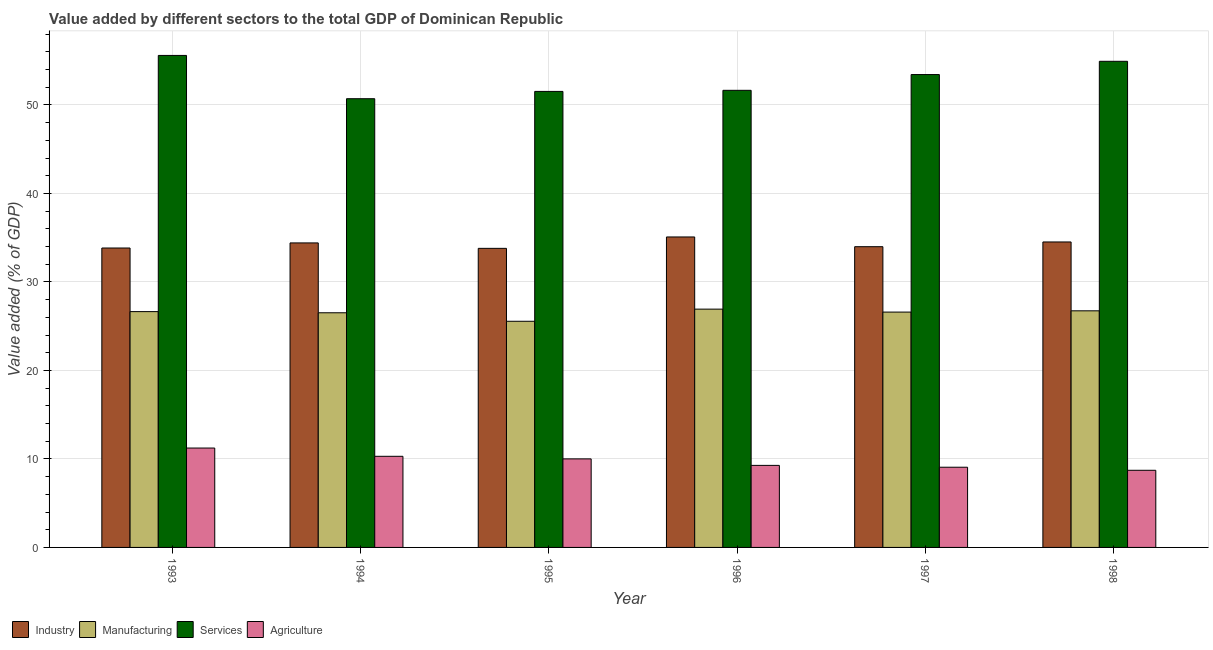How many different coloured bars are there?
Your response must be concise. 4. Are the number of bars on each tick of the X-axis equal?
Provide a short and direct response. Yes. How many bars are there on the 1st tick from the left?
Offer a terse response. 4. How many bars are there on the 1st tick from the right?
Keep it short and to the point. 4. What is the value added by industrial sector in 1998?
Keep it short and to the point. 34.52. Across all years, what is the maximum value added by manufacturing sector?
Keep it short and to the point. 26.93. Across all years, what is the minimum value added by manufacturing sector?
Your response must be concise. 25.56. In which year was the value added by services sector minimum?
Provide a succinct answer. 1994. What is the total value added by services sector in the graph?
Make the answer very short. 317.86. What is the difference between the value added by industrial sector in 1993 and that in 1995?
Your answer should be compact. 0.04. What is the difference between the value added by services sector in 1995 and the value added by industrial sector in 1998?
Provide a short and direct response. -3.4. What is the average value added by agricultural sector per year?
Offer a very short reply. 9.76. What is the ratio of the value added by industrial sector in 1993 to that in 1995?
Provide a short and direct response. 1. Is the value added by services sector in 1994 less than that in 1998?
Your answer should be very brief. Yes. What is the difference between the highest and the second highest value added by manufacturing sector?
Your answer should be compact. 0.19. What is the difference between the highest and the lowest value added by industrial sector?
Give a very brief answer. 1.29. In how many years, is the value added by services sector greater than the average value added by services sector taken over all years?
Offer a terse response. 3. Is the sum of the value added by agricultural sector in 1993 and 1997 greater than the maximum value added by services sector across all years?
Make the answer very short. Yes. What does the 3rd bar from the left in 1993 represents?
Your answer should be very brief. Services. What does the 4th bar from the right in 1998 represents?
Provide a succinct answer. Industry. Is it the case that in every year, the sum of the value added by industrial sector and value added by manufacturing sector is greater than the value added by services sector?
Your answer should be very brief. Yes. How many years are there in the graph?
Your answer should be compact. 6. What is the difference between two consecutive major ticks on the Y-axis?
Give a very brief answer. 10. Where does the legend appear in the graph?
Offer a terse response. Bottom left. How are the legend labels stacked?
Your answer should be compact. Horizontal. What is the title of the graph?
Give a very brief answer. Value added by different sectors to the total GDP of Dominican Republic. Does "Natural Gas" appear as one of the legend labels in the graph?
Your answer should be compact. No. What is the label or title of the Y-axis?
Your response must be concise. Value added (% of GDP). What is the Value added (% of GDP) of Industry in 1993?
Give a very brief answer. 33.84. What is the Value added (% of GDP) in Manufacturing in 1993?
Ensure brevity in your answer.  26.65. What is the Value added (% of GDP) of Services in 1993?
Make the answer very short. 55.6. What is the Value added (% of GDP) in Agriculture in 1993?
Give a very brief answer. 11.23. What is the Value added (% of GDP) in Industry in 1994?
Your answer should be compact. 34.41. What is the Value added (% of GDP) in Manufacturing in 1994?
Offer a terse response. 26.52. What is the Value added (% of GDP) in Services in 1994?
Keep it short and to the point. 50.71. What is the Value added (% of GDP) in Agriculture in 1994?
Make the answer very short. 10.3. What is the Value added (% of GDP) in Industry in 1995?
Keep it short and to the point. 33.8. What is the Value added (% of GDP) of Manufacturing in 1995?
Give a very brief answer. 25.56. What is the Value added (% of GDP) in Services in 1995?
Ensure brevity in your answer.  51.53. What is the Value added (% of GDP) of Agriculture in 1995?
Provide a short and direct response. 10.01. What is the Value added (% of GDP) of Industry in 1996?
Offer a very short reply. 35.08. What is the Value added (% of GDP) in Manufacturing in 1996?
Provide a succinct answer. 26.93. What is the Value added (% of GDP) in Services in 1996?
Your response must be concise. 51.66. What is the Value added (% of GDP) of Agriculture in 1996?
Your answer should be compact. 9.27. What is the Value added (% of GDP) in Industry in 1997?
Your answer should be very brief. 33.98. What is the Value added (% of GDP) in Manufacturing in 1997?
Ensure brevity in your answer.  26.59. What is the Value added (% of GDP) in Services in 1997?
Keep it short and to the point. 53.44. What is the Value added (% of GDP) in Agriculture in 1997?
Your answer should be very brief. 9.06. What is the Value added (% of GDP) of Industry in 1998?
Give a very brief answer. 34.52. What is the Value added (% of GDP) in Manufacturing in 1998?
Offer a terse response. 26.74. What is the Value added (% of GDP) of Services in 1998?
Your answer should be very brief. 54.93. What is the Value added (% of GDP) in Agriculture in 1998?
Keep it short and to the point. 8.72. Across all years, what is the maximum Value added (% of GDP) of Industry?
Offer a very short reply. 35.08. Across all years, what is the maximum Value added (% of GDP) of Manufacturing?
Your answer should be compact. 26.93. Across all years, what is the maximum Value added (% of GDP) of Services?
Offer a terse response. 55.6. Across all years, what is the maximum Value added (% of GDP) of Agriculture?
Ensure brevity in your answer.  11.23. Across all years, what is the minimum Value added (% of GDP) of Industry?
Make the answer very short. 33.8. Across all years, what is the minimum Value added (% of GDP) in Manufacturing?
Provide a short and direct response. 25.56. Across all years, what is the minimum Value added (% of GDP) of Services?
Your answer should be compact. 50.71. Across all years, what is the minimum Value added (% of GDP) of Agriculture?
Make the answer very short. 8.72. What is the total Value added (% of GDP) of Industry in the graph?
Keep it short and to the point. 205.63. What is the total Value added (% of GDP) in Manufacturing in the graph?
Make the answer very short. 158.98. What is the total Value added (% of GDP) in Services in the graph?
Provide a short and direct response. 317.86. What is the total Value added (% of GDP) of Agriculture in the graph?
Your answer should be very brief. 58.59. What is the difference between the Value added (% of GDP) of Industry in 1993 and that in 1994?
Your response must be concise. -0.57. What is the difference between the Value added (% of GDP) in Manufacturing in 1993 and that in 1994?
Your answer should be very brief. 0.13. What is the difference between the Value added (% of GDP) in Services in 1993 and that in 1994?
Ensure brevity in your answer.  4.89. What is the difference between the Value added (% of GDP) in Agriculture in 1993 and that in 1994?
Provide a succinct answer. 0.93. What is the difference between the Value added (% of GDP) of Industry in 1993 and that in 1995?
Provide a succinct answer. 0.04. What is the difference between the Value added (% of GDP) of Manufacturing in 1993 and that in 1995?
Your response must be concise. 1.09. What is the difference between the Value added (% of GDP) in Services in 1993 and that in 1995?
Provide a short and direct response. 4.07. What is the difference between the Value added (% of GDP) in Agriculture in 1993 and that in 1995?
Your answer should be compact. 1.23. What is the difference between the Value added (% of GDP) of Industry in 1993 and that in 1996?
Provide a succinct answer. -1.25. What is the difference between the Value added (% of GDP) of Manufacturing in 1993 and that in 1996?
Your answer should be very brief. -0.28. What is the difference between the Value added (% of GDP) in Services in 1993 and that in 1996?
Provide a short and direct response. 3.94. What is the difference between the Value added (% of GDP) of Agriculture in 1993 and that in 1996?
Provide a succinct answer. 1.96. What is the difference between the Value added (% of GDP) of Industry in 1993 and that in 1997?
Provide a succinct answer. -0.15. What is the difference between the Value added (% of GDP) of Manufacturing in 1993 and that in 1997?
Your response must be concise. 0.05. What is the difference between the Value added (% of GDP) in Services in 1993 and that in 1997?
Your response must be concise. 2.16. What is the difference between the Value added (% of GDP) in Agriculture in 1993 and that in 1997?
Give a very brief answer. 2.17. What is the difference between the Value added (% of GDP) in Industry in 1993 and that in 1998?
Give a very brief answer. -0.68. What is the difference between the Value added (% of GDP) of Manufacturing in 1993 and that in 1998?
Provide a succinct answer. -0.09. What is the difference between the Value added (% of GDP) in Services in 1993 and that in 1998?
Your answer should be compact. 0.66. What is the difference between the Value added (% of GDP) of Agriculture in 1993 and that in 1998?
Your answer should be compact. 2.51. What is the difference between the Value added (% of GDP) in Industry in 1994 and that in 1995?
Your answer should be very brief. 0.61. What is the difference between the Value added (% of GDP) in Manufacturing in 1994 and that in 1995?
Offer a terse response. 0.96. What is the difference between the Value added (% of GDP) of Services in 1994 and that in 1995?
Offer a terse response. -0.83. What is the difference between the Value added (% of GDP) in Agriculture in 1994 and that in 1995?
Ensure brevity in your answer.  0.29. What is the difference between the Value added (% of GDP) in Industry in 1994 and that in 1996?
Provide a short and direct response. -0.67. What is the difference between the Value added (% of GDP) of Manufacturing in 1994 and that in 1996?
Make the answer very short. -0.41. What is the difference between the Value added (% of GDP) of Services in 1994 and that in 1996?
Provide a short and direct response. -0.95. What is the difference between the Value added (% of GDP) in Agriculture in 1994 and that in 1996?
Your response must be concise. 1.03. What is the difference between the Value added (% of GDP) in Industry in 1994 and that in 1997?
Provide a short and direct response. 0.43. What is the difference between the Value added (% of GDP) of Manufacturing in 1994 and that in 1997?
Offer a very short reply. -0.08. What is the difference between the Value added (% of GDP) in Services in 1994 and that in 1997?
Ensure brevity in your answer.  -2.73. What is the difference between the Value added (% of GDP) in Agriculture in 1994 and that in 1997?
Provide a succinct answer. 1.23. What is the difference between the Value added (% of GDP) of Industry in 1994 and that in 1998?
Give a very brief answer. -0.11. What is the difference between the Value added (% of GDP) in Manufacturing in 1994 and that in 1998?
Offer a terse response. -0.22. What is the difference between the Value added (% of GDP) in Services in 1994 and that in 1998?
Your response must be concise. -4.23. What is the difference between the Value added (% of GDP) of Agriculture in 1994 and that in 1998?
Give a very brief answer. 1.58. What is the difference between the Value added (% of GDP) in Industry in 1995 and that in 1996?
Offer a terse response. -1.29. What is the difference between the Value added (% of GDP) of Manufacturing in 1995 and that in 1996?
Your answer should be compact. -1.37. What is the difference between the Value added (% of GDP) in Services in 1995 and that in 1996?
Offer a very short reply. -0.12. What is the difference between the Value added (% of GDP) in Agriculture in 1995 and that in 1996?
Give a very brief answer. 0.73. What is the difference between the Value added (% of GDP) of Industry in 1995 and that in 1997?
Keep it short and to the point. -0.19. What is the difference between the Value added (% of GDP) in Manufacturing in 1995 and that in 1997?
Your response must be concise. -1.04. What is the difference between the Value added (% of GDP) of Services in 1995 and that in 1997?
Your response must be concise. -1.91. What is the difference between the Value added (% of GDP) of Agriculture in 1995 and that in 1997?
Give a very brief answer. 0.94. What is the difference between the Value added (% of GDP) of Industry in 1995 and that in 1998?
Give a very brief answer. -0.72. What is the difference between the Value added (% of GDP) in Manufacturing in 1995 and that in 1998?
Give a very brief answer. -1.18. What is the difference between the Value added (% of GDP) of Services in 1995 and that in 1998?
Provide a succinct answer. -3.4. What is the difference between the Value added (% of GDP) in Agriculture in 1995 and that in 1998?
Your answer should be very brief. 1.29. What is the difference between the Value added (% of GDP) in Industry in 1996 and that in 1997?
Provide a short and direct response. 1.1. What is the difference between the Value added (% of GDP) of Manufacturing in 1996 and that in 1997?
Your answer should be very brief. 0.33. What is the difference between the Value added (% of GDP) of Services in 1996 and that in 1997?
Provide a succinct answer. -1.78. What is the difference between the Value added (% of GDP) of Agriculture in 1996 and that in 1997?
Offer a very short reply. 0.21. What is the difference between the Value added (% of GDP) of Industry in 1996 and that in 1998?
Keep it short and to the point. 0.57. What is the difference between the Value added (% of GDP) of Manufacturing in 1996 and that in 1998?
Offer a very short reply. 0.19. What is the difference between the Value added (% of GDP) in Services in 1996 and that in 1998?
Provide a succinct answer. -3.28. What is the difference between the Value added (% of GDP) of Agriculture in 1996 and that in 1998?
Provide a succinct answer. 0.55. What is the difference between the Value added (% of GDP) in Industry in 1997 and that in 1998?
Ensure brevity in your answer.  -0.54. What is the difference between the Value added (% of GDP) of Manufacturing in 1997 and that in 1998?
Offer a very short reply. -0.14. What is the difference between the Value added (% of GDP) of Services in 1997 and that in 1998?
Offer a terse response. -1.5. What is the difference between the Value added (% of GDP) of Agriculture in 1997 and that in 1998?
Give a very brief answer. 0.35. What is the difference between the Value added (% of GDP) in Industry in 1993 and the Value added (% of GDP) in Manufacturing in 1994?
Keep it short and to the point. 7.32. What is the difference between the Value added (% of GDP) in Industry in 1993 and the Value added (% of GDP) in Services in 1994?
Offer a terse response. -16.87. What is the difference between the Value added (% of GDP) of Industry in 1993 and the Value added (% of GDP) of Agriculture in 1994?
Provide a succinct answer. 23.54. What is the difference between the Value added (% of GDP) of Manufacturing in 1993 and the Value added (% of GDP) of Services in 1994?
Your response must be concise. -24.06. What is the difference between the Value added (% of GDP) in Manufacturing in 1993 and the Value added (% of GDP) in Agriculture in 1994?
Your response must be concise. 16.35. What is the difference between the Value added (% of GDP) in Services in 1993 and the Value added (% of GDP) in Agriculture in 1994?
Keep it short and to the point. 45.3. What is the difference between the Value added (% of GDP) in Industry in 1993 and the Value added (% of GDP) in Manufacturing in 1995?
Give a very brief answer. 8.28. What is the difference between the Value added (% of GDP) of Industry in 1993 and the Value added (% of GDP) of Services in 1995?
Your answer should be very brief. -17.7. What is the difference between the Value added (% of GDP) in Industry in 1993 and the Value added (% of GDP) in Agriculture in 1995?
Offer a terse response. 23.83. What is the difference between the Value added (% of GDP) in Manufacturing in 1993 and the Value added (% of GDP) in Services in 1995?
Keep it short and to the point. -24.88. What is the difference between the Value added (% of GDP) in Manufacturing in 1993 and the Value added (% of GDP) in Agriculture in 1995?
Provide a short and direct response. 16.64. What is the difference between the Value added (% of GDP) of Services in 1993 and the Value added (% of GDP) of Agriculture in 1995?
Make the answer very short. 45.59. What is the difference between the Value added (% of GDP) in Industry in 1993 and the Value added (% of GDP) in Manufacturing in 1996?
Ensure brevity in your answer.  6.91. What is the difference between the Value added (% of GDP) in Industry in 1993 and the Value added (% of GDP) in Services in 1996?
Make the answer very short. -17.82. What is the difference between the Value added (% of GDP) of Industry in 1993 and the Value added (% of GDP) of Agriculture in 1996?
Make the answer very short. 24.56. What is the difference between the Value added (% of GDP) of Manufacturing in 1993 and the Value added (% of GDP) of Services in 1996?
Provide a short and direct response. -25.01. What is the difference between the Value added (% of GDP) in Manufacturing in 1993 and the Value added (% of GDP) in Agriculture in 1996?
Ensure brevity in your answer.  17.38. What is the difference between the Value added (% of GDP) of Services in 1993 and the Value added (% of GDP) of Agriculture in 1996?
Give a very brief answer. 46.33. What is the difference between the Value added (% of GDP) of Industry in 1993 and the Value added (% of GDP) of Manufacturing in 1997?
Your response must be concise. 7.24. What is the difference between the Value added (% of GDP) of Industry in 1993 and the Value added (% of GDP) of Services in 1997?
Give a very brief answer. -19.6. What is the difference between the Value added (% of GDP) in Industry in 1993 and the Value added (% of GDP) in Agriculture in 1997?
Your answer should be very brief. 24.77. What is the difference between the Value added (% of GDP) in Manufacturing in 1993 and the Value added (% of GDP) in Services in 1997?
Make the answer very short. -26.79. What is the difference between the Value added (% of GDP) of Manufacturing in 1993 and the Value added (% of GDP) of Agriculture in 1997?
Your answer should be compact. 17.58. What is the difference between the Value added (% of GDP) of Services in 1993 and the Value added (% of GDP) of Agriculture in 1997?
Offer a very short reply. 46.53. What is the difference between the Value added (% of GDP) in Industry in 1993 and the Value added (% of GDP) in Manufacturing in 1998?
Ensure brevity in your answer.  7.1. What is the difference between the Value added (% of GDP) of Industry in 1993 and the Value added (% of GDP) of Services in 1998?
Provide a short and direct response. -21.1. What is the difference between the Value added (% of GDP) of Industry in 1993 and the Value added (% of GDP) of Agriculture in 1998?
Provide a short and direct response. 25.12. What is the difference between the Value added (% of GDP) of Manufacturing in 1993 and the Value added (% of GDP) of Services in 1998?
Make the answer very short. -28.29. What is the difference between the Value added (% of GDP) in Manufacturing in 1993 and the Value added (% of GDP) in Agriculture in 1998?
Offer a very short reply. 17.93. What is the difference between the Value added (% of GDP) of Services in 1993 and the Value added (% of GDP) of Agriculture in 1998?
Your answer should be compact. 46.88. What is the difference between the Value added (% of GDP) of Industry in 1994 and the Value added (% of GDP) of Manufacturing in 1995?
Make the answer very short. 8.85. What is the difference between the Value added (% of GDP) in Industry in 1994 and the Value added (% of GDP) in Services in 1995?
Give a very brief answer. -17.12. What is the difference between the Value added (% of GDP) in Industry in 1994 and the Value added (% of GDP) in Agriculture in 1995?
Provide a short and direct response. 24.4. What is the difference between the Value added (% of GDP) in Manufacturing in 1994 and the Value added (% of GDP) in Services in 1995?
Keep it short and to the point. -25.01. What is the difference between the Value added (% of GDP) in Manufacturing in 1994 and the Value added (% of GDP) in Agriculture in 1995?
Your answer should be compact. 16.51. What is the difference between the Value added (% of GDP) of Services in 1994 and the Value added (% of GDP) of Agriculture in 1995?
Offer a terse response. 40.7. What is the difference between the Value added (% of GDP) of Industry in 1994 and the Value added (% of GDP) of Manufacturing in 1996?
Your response must be concise. 7.48. What is the difference between the Value added (% of GDP) of Industry in 1994 and the Value added (% of GDP) of Services in 1996?
Your response must be concise. -17.24. What is the difference between the Value added (% of GDP) in Industry in 1994 and the Value added (% of GDP) in Agriculture in 1996?
Give a very brief answer. 25.14. What is the difference between the Value added (% of GDP) in Manufacturing in 1994 and the Value added (% of GDP) in Services in 1996?
Provide a succinct answer. -25.14. What is the difference between the Value added (% of GDP) in Manufacturing in 1994 and the Value added (% of GDP) in Agriculture in 1996?
Ensure brevity in your answer.  17.25. What is the difference between the Value added (% of GDP) in Services in 1994 and the Value added (% of GDP) in Agriculture in 1996?
Provide a short and direct response. 41.43. What is the difference between the Value added (% of GDP) in Industry in 1994 and the Value added (% of GDP) in Manufacturing in 1997?
Make the answer very short. 7.82. What is the difference between the Value added (% of GDP) of Industry in 1994 and the Value added (% of GDP) of Services in 1997?
Your response must be concise. -19.03. What is the difference between the Value added (% of GDP) in Industry in 1994 and the Value added (% of GDP) in Agriculture in 1997?
Your response must be concise. 25.35. What is the difference between the Value added (% of GDP) of Manufacturing in 1994 and the Value added (% of GDP) of Services in 1997?
Your response must be concise. -26.92. What is the difference between the Value added (% of GDP) of Manufacturing in 1994 and the Value added (% of GDP) of Agriculture in 1997?
Provide a short and direct response. 17.45. What is the difference between the Value added (% of GDP) of Services in 1994 and the Value added (% of GDP) of Agriculture in 1997?
Provide a succinct answer. 41.64. What is the difference between the Value added (% of GDP) in Industry in 1994 and the Value added (% of GDP) in Manufacturing in 1998?
Offer a very short reply. 7.67. What is the difference between the Value added (% of GDP) in Industry in 1994 and the Value added (% of GDP) in Services in 1998?
Offer a very short reply. -20.52. What is the difference between the Value added (% of GDP) in Industry in 1994 and the Value added (% of GDP) in Agriculture in 1998?
Your answer should be compact. 25.69. What is the difference between the Value added (% of GDP) of Manufacturing in 1994 and the Value added (% of GDP) of Services in 1998?
Keep it short and to the point. -28.42. What is the difference between the Value added (% of GDP) in Manufacturing in 1994 and the Value added (% of GDP) in Agriculture in 1998?
Offer a terse response. 17.8. What is the difference between the Value added (% of GDP) of Services in 1994 and the Value added (% of GDP) of Agriculture in 1998?
Offer a terse response. 41.99. What is the difference between the Value added (% of GDP) in Industry in 1995 and the Value added (% of GDP) in Manufacturing in 1996?
Provide a succinct answer. 6.87. What is the difference between the Value added (% of GDP) in Industry in 1995 and the Value added (% of GDP) in Services in 1996?
Provide a succinct answer. -17.86. What is the difference between the Value added (% of GDP) in Industry in 1995 and the Value added (% of GDP) in Agriculture in 1996?
Keep it short and to the point. 24.52. What is the difference between the Value added (% of GDP) of Manufacturing in 1995 and the Value added (% of GDP) of Services in 1996?
Offer a very short reply. -26.1. What is the difference between the Value added (% of GDP) of Manufacturing in 1995 and the Value added (% of GDP) of Agriculture in 1996?
Give a very brief answer. 16.29. What is the difference between the Value added (% of GDP) in Services in 1995 and the Value added (% of GDP) in Agriculture in 1996?
Provide a succinct answer. 42.26. What is the difference between the Value added (% of GDP) of Industry in 1995 and the Value added (% of GDP) of Manufacturing in 1997?
Provide a short and direct response. 7.2. What is the difference between the Value added (% of GDP) in Industry in 1995 and the Value added (% of GDP) in Services in 1997?
Your answer should be compact. -19.64. What is the difference between the Value added (% of GDP) of Industry in 1995 and the Value added (% of GDP) of Agriculture in 1997?
Offer a terse response. 24.73. What is the difference between the Value added (% of GDP) in Manufacturing in 1995 and the Value added (% of GDP) in Services in 1997?
Ensure brevity in your answer.  -27.88. What is the difference between the Value added (% of GDP) of Manufacturing in 1995 and the Value added (% of GDP) of Agriculture in 1997?
Offer a very short reply. 16.49. What is the difference between the Value added (% of GDP) in Services in 1995 and the Value added (% of GDP) in Agriculture in 1997?
Your answer should be compact. 42.47. What is the difference between the Value added (% of GDP) of Industry in 1995 and the Value added (% of GDP) of Manufacturing in 1998?
Make the answer very short. 7.06. What is the difference between the Value added (% of GDP) in Industry in 1995 and the Value added (% of GDP) in Services in 1998?
Keep it short and to the point. -21.14. What is the difference between the Value added (% of GDP) in Industry in 1995 and the Value added (% of GDP) in Agriculture in 1998?
Provide a succinct answer. 25.08. What is the difference between the Value added (% of GDP) in Manufacturing in 1995 and the Value added (% of GDP) in Services in 1998?
Provide a succinct answer. -29.38. What is the difference between the Value added (% of GDP) of Manufacturing in 1995 and the Value added (% of GDP) of Agriculture in 1998?
Keep it short and to the point. 16.84. What is the difference between the Value added (% of GDP) of Services in 1995 and the Value added (% of GDP) of Agriculture in 1998?
Your answer should be compact. 42.81. What is the difference between the Value added (% of GDP) in Industry in 1996 and the Value added (% of GDP) in Manufacturing in 1997?
Make the answer very short. 8.49. What is the difference between the Value added (% of GDP) in Industry in 1996 and the Value added (% of GDP) in Services in 1997?
Your answer should be very brief. -18.35. What is the difference between the Value added (% of GDP) of Industry in 1996 and the Value added (% of GDP) of Agriculture in 1997?
Make the answer very short. 26.02. What is the difference between the Value added (% of GDP) of Manufacturing in 1996 and the Value added (% of GDP) of Services in 1997?
Offer a terse response. -26.51. What is the difference between the Value added (% of GDP) of Manufacturing in 1996 and the Value added (% of GDP) of Agriculture in 1997?
Your response must be concise. 17.86. What is the difference between the Value added (% of GDP) of Services in 1996 and the Value added (% of GDP) of Agriculture in 1997?
Keep it short and to the point. 42.59. What is the difference between the Value added (% of GDP) of Industry in 1996 and the Value added (% of GDP) of Manufacturing in 1998?
Make the answer very short. 8.35. What is the difference between the Value added (% of GDP) in Industry in 1996 and the Value added (% of GDP) in Services in 1998?
Your answer should be very brief. -19.85. What is the difference between the Value added (% of GDP) in Industry in 1996 and the Value added (% of GDP) in Agriculture in 1998?
Give a very brief answer. 26.37. What is the difference between the Value added (% of GDP) in Manufacturing in 1996 and the Value added (% of GDP) in Services in 1998?
Keep it short and to the point. -28.01. What is the difference between the Value added (% of GDP) in Manufacturing in 1996 and the Value added (% of GDP) in Agriculture in 1998?
Your answer should be very brief. 18.21. What is the difference between the Value added (% of GDP) in Services in 1996 and the Value added (% of GDP) in Agriculture in 1998?
Give a very brief answer. 42.94. What is the difference between the Value added (% of GDP) of Industry in 1997 and the Value added (% of GDP) of Manufacturing in 1998?
Give a very brief answer. 7.25. What is the difference between the Value added (% of GDP) in Industry in 1997 and the Value added (% of GDP) in Services in 1998?
Your answer should be compact. -20.95. What is the difference between the Value added (% of GDP) of Industry in 1997 and the Value added (% of GDP) of Agriculture in 1998?
Keep it short and to the point. 25.27. What is the difference between the Value added (% of GDP) in Manufacturing in 1997 and the Value added (% of GDP) in Services in 1998?
Give a very brief answer. -28.34. What is the difference between the Value added (% of GDP) of Manufacturing in 1997 and the Value added (% of GDP) of Agriculture in 1998?
Provide a succinct answer. 17.88. What is the difference between the Value added (% of GDP) of Services in 1997 and the Value added (% of GDP) of Agriculture in 1998?
Give a very brief answer. 44.72. What is the average Value added (% of GDP) of Industry per year?
Make the answer very short. 34.27. What is the average Value added (% of GDP) of Manufacturing per year?
Your response must be concise. 26.5. What is the average Value added (% of GDP) of Services per year?
Provide a short and direct response. 52.98. What is the average Value added (% of GDP) in Agriculture per year?
Offer a very short reply. 9.76. In the year 1993, what is the difference between the Value added (% of GDP) in Industry and Value added (% of GDP) in Manufacturing?
Provide a succinct answer. 7.19. In the year 1993, what is the difference between the Value added (% of GDP) in Industry and Value added (% of GDP) in Services?
Offer a terse response. -21.76. In the year 1993, what is the difference between the Value added (% of GDP) of Industry and Value added (% of GDP) of Agriculture?
Give a very brief answer. 22.6. In the year 1993, what is the difference between the Value added (% of GDP) of Manufacturing and Value added (% of GDP) of Services?
Provide a succinct answer. -28.95. In the year 1993, what is the difference between the Value added (% of GDP) of Manufacturing and Value added (% of GDP) of Agriculture?
Your answer should be very brief. 15.42. In the year 1993, what is the difference between the Value added (% of GDP) of Services and Value added (% of GDP) of Agriculture?
Ensure brevity in your answer.  44.37. In the year 1994, what is the difference between the Value added (% of GDP) of Industry and Value added (% of GDP) of Manufacturing?
Provide a short and direct response. 7.89. In the year 1994, what is the difference between the Value added (% of GDP) of Industry and Value added (% of GDP) of Services?
Your answer should be very brief. -16.3. In the year 1994, what is the difference between the Value added (% of GDP) in Industry and Value added (% of GDP) in Agriculture?
Provide a succinct answer. 24.11. In the year 1994, what is the difference between the Value added (% of GDP) of Manufacturing and Value added (% of GDP) of Services?
Offer a very short reply. -24.19. In the year 1994, what is the difference between the Value added (% of GDP) in Manufacturing and Value added (% of GDP) in Agriculture?
Make the answer very short. 16.22. In the year 1994, what is the difference between the Value added (% of GDP) in Services and Value added (% of GDP) in Agriculture?
Make the answer very short. 40.41. In the year 1995, what is the difference between the Value added (% of GDP) in Industry and Value added (% of GDP) in Manufacturing?
Ensure brevity in your answer.  8.24. In the year 1995, what is the difference between the Value added (% of GDP) of Industry and Value added (% of GDP) of Services?
Provide a short and direct response. -17.73. In the year 1995, what is the difference between the Value added (% of GDP) in Industry and Value added (% of GDP) in Agriculture?
Provide a succinct answer. 23.79. In the year 1995, what is the difference between the Value added (% of GDP) in Manufacturing and Value added (% of GDP) in Services?
Offer a terse response. -25.97. In the year 1995, what is the difference between the Value added (% of GDP) of Manufacturing and Value added (% of GDP) of Agriculture?
Ensure brevity in your answer.  15.55. In the year 1995, what is the difference between the Value added (% of GDP) in Services and Value added (% of GDP) in Agriculture?
Provide a succinct answer. 41.52. In the year 1996, what is the difference between the Value added (% of GDP) of Industry and Value added (% of GDP) of Manufacturing?
Give a very brief answer. 8.16. In the year 1996, what is the difference between the Value added (% of GDP) of Industry and Value added (% of GDP) of Services?
Your answer should be very brief. -16.57. In the year 1996, what is the difference between the Value added (% of GDP) in Industry and Value added (% of GDP) in Agriculture?
Your answer should be very brief. 25.81. In the year 1996, what is the difference between the Value added (% of GDP) of Manufacturing and Value added (% of GDP) of Services?
Your response must be concise. -24.73. In the year 1996, what is the difference between the Value added (% of GDP) of Manufacturing and Value added (% of GDP) of Agriculture?
Make the answer very short. 17.66. In the year 1996, what is the difference between the Value added (% of GDP) in Services and Value added (% of GDP) in Agriculture?
Ensure brevity in your answer.  42.38. In the year 1997, what is the difference between the Value added (% of GDP) of Industry and Value added (% of GDP) of Manufacturing?
Your response must be concise. 7.39. In the year 1997, what is the difference between the Value added (% of GDP) of Industry and Value added (% of GDP) of Services?
Provide a succinct answer. -19.45. In the year 1997, what is the difference between the Value added (% of GDP) in Industry and Value added (% of GDP) in Agriculture?
Provide a short and direct response. 24.92. In the year 1997, what is the difference between the Value added (% of GDP) of Manufacturing and Value added (% of GDP) of Services?
Your response must be concise. -26.84. In the year 1997, what is the difference between the Value added (% of GDP) of Manufacturing and Value added (% of GDP) of Agriculture?
Give a very brief answer. 17.53. In the year 1997, what is the difference between the Value added (% of GDP) in Services and Value added (% of GDP) in Agriculture?
Keep it short and to the point. 44.37. In the year 1998, what is the difference between the Value added (% of GDP) in Industry and Value added (% of GDP) in Manufacturing?
Give a very brief answer. 7.78. In the year 1998, what is the difference between the Value added (% of GDP) in Industry and Value added (% of GDP) in Services?
Provide a short and direct response. -20.41. In the year 1998, what is the difference between the Value added (% of GDP) of Industry and Value added (% of GDP) of Agriculture?
Your response must be concise. 25.8. In the year 1998, what is the difference between the Value added (% of GDP) of Manufacturing and Value added (% of GDP) of Services?
Give a very brief answer. -28.2. In the year 1998, what is the difference between the Value added (% of GDP) of Manufacturing and Value added (% of GDP) of Agriculture?
Your answer should be very brief. 18.02. In the year 1998, what is the difference between the Value added (% of GDP) of Services and Value added (% of GDP) of Agriculture?
Make the answer very short. 46.22. What is the ratio of the Value added (% of GDP) in Industry in 1993 to that in 1994?
Make the answer very short. 0.98. What is the ratio of the Value added (% of GDP) of Services in 1993 to that in 1994?
Keep it short and to the point. 1.1. What is the ratio of the Value added (% of GDP) of Agriculture in 1993 to that in 1994?
Provide a short and direct response. 1.09. What is the ratio of the Value added (% of GDP) in Manufacturing in 1993 to that in 1995?
Offer a terse response. 1.04. What is the ratio of the Value added (% of GDP) of Services in 1993 to that in 1995?
Ensure brevity in your answer.  1.08. What is the ratio of the Value added (% of GDP) in Agriculture in 1993 to that in 1995?
Your answer should be compact. 1.12. What is the ratio of the Value added (% of GDP) in Industry in 1993 to that in 1996?
Give a very brief answer. 0.96. What is the ratio of the Value added (% of GDP) in Manufacturing in 1993 to that in 1996?
Keep it short and to the point. 0.99. What is the ratio of the Value added (% of GDP) in Services in 1993 to that in 1996?
Give a very brief answer. 1.08. What is the ratio of the Value added (% of GDP) of Agriculture in 1993 to that in 1996?
Keep it short and to the point. 1.21. What is the ratio of the Value added (% of GDP) in Services in 1993 to that in 1997?
Give a very brief answer. 1.04. What is the ratio of the Value added (% of GDP) of Agriculture in 1993 to that in 1997?
Give a very brief answer. 1.24. What is the ratio of the Value added (% of GDP) in Industry in 1993 to that in 1998?
Make the answer very short. 0.98. What is the ratio of the Value added (% of GDP) in Manufacturing in 1993 to that in 1998?
Give a very brief answer. 1. What is the ratio of the Value added (% of GDP) in Services in 1993 to that in 1998?
Offer a very short reply. 1.01. What is the ratio of the Value added (% of GDP) in Agriculture in 1993 to that in 1998?
Keep it short and to the point. 1.29. What is the ratio of the Value added (% of GDP) in Industry in 1994 to that in 1995?
Your answer should be compact. 1.02. What is the ratio of the Value added (% of GDP) of Manufacturing in 1994 to that in 1995?
Make the answer very short. 1.04. What is the ratio of the Value added (% of GDP) in Services in 1994 to that in 1995?
Ensure brevity in your answer.  0.98. What is the ratio of the Value added (% of GDP) in Agriculture in 1994 to that in 1995?
Your response must be concise. 1.03. What is the ratio of the Value added (% of GDP) in Industry in 1994 to that in 1996?
Offer a terse response. 0.98. What is the ratio of the Value added (% of GDP) in Manufacturing in 1994 to that in 1996?
Keep it short and to the point. 0.98. What is the ratio of the Value added (% of GDP) in Services in 1994 to that in 1996?
Ensure brevity in your answer.  0.98. What is the ratio of the Value added (% of GDP) of Agriculture in 1994 to that in 1996?
Ensure brevity in your answer.  1.11. What is the ratio of the Value added (% of GDP) of Industry in 1994 to that in 1997?
Ensure brevity in your answer.  1.01. What is the ratio of the Value added (% of GDP) in Services in 1994 to that in 1997?
Provide a succinct answer. 0.95. What is the ratio of the Value added (% of GDP) of Agriculture in 1994 to that in 1997?
Keep it short and to the point. 1.14. What is the ratio of the Value added (% of GDP) in Services in 1994 to that in 1998?
Ensure brevity in your answer.  0.92. What is the ratio of the Value added (% of GDP) of Agriculture in 1994 to that in 1998?
Provide a succinct answer. 1.18. What is the ratio of the Value added (% of GDP) in Industry in 1995 to that in 1996?
Offer a very short reply. 0.96. What is the ratio of the Value added (% of GDP) in Manufacturing in 1995 to that in 1996?
Provide a short and direct response. 0.95. What is the ratio of the Value added (% of GDP) in Agriculture in 1995 to that in 1996?
Provide a short and direct response. 1.08. What is the ratio of the Value added (% of GDP) in Manufacturing in 1995 to that in 1997?
Offer a terse response. 0.96. What is the ratio of the Value added (% of GDP) in Services in 1995 to that in 1997?
Your response must be concise. 0.96. What is the ratio of the Value added (% of GDP) in Agriculture in 1995 to that in 1997?
Give a very brief answer. 1.1. What is the ratio of the Value added (% of GDP) in Industry in 1995 to that in 1998?
Your response must be concise. 0.98. What is the ratio of the Value added (% of GDP) of Manufacturing in 1995 to that in 1998?
Provide a short and direct response. 0.96. What is the ratio of the Value added (% of GDP) in Services in 1995 to that in 1998?
Give a very brief answer. 0.94. What is the ratio of the Value added (% of GDP) of Agriculture in 1995 to that in 1998?
Give a very brief answer. 1.15. What is the ratio of the Value added (% of GDP) of Industry in 1996 to that in 1997?
Make the answer very short. 1.03. What is the ratio of the Value added (% of GDP) of Manufacturing in 1996 to that in 1997?
Give a very brief answer. 1.01. What is the ratio of the Value added (% of GDP) in Services in 1996 to that in 1997?
Provide a succinct answer. 0.97. What is the ratio of the Value added (% of GDP) in Agriculture in 1996 to that in 1997?
Your answer should be very brief. 1.02. What is the ratio of the Value added (% of GDP) of Industry in 1996 to that in 1998?
Ensure brevity in your answer.  1.02. What is the ratio of the Value added (% of GDP) of Manufacturing in 1996 to that in 1998?
Keep it short and to the point. 1.01. What is the ratio of the Value added (% of GDP) of Services in 1996 to that in 1998?
Provide a succinct answer. 0.94. What is the ratio of the Value added (% of GDP) of Agriculture in 1996 to that in 1998?
Give a very brief answer. 1.06. What is the ratio of the Value added (% of GDP) of Industry in 1997 to that in 1998?
Ensure brevity in your answer.  0.98. What is the ratio of the Value added (% of GDP) of Manufacturing in 1997 to that in 1998?
Keep it short and to the point. 0.99. What is the ratio of the Value added (% of GDP) in Services in 1997 to that in 1998?
Keep it short and to the point. 0.97. What is the ratio of the Value added (% of GDP) of Agriculture in 1997 to that in 1998?
Give a very brief answer. 1.04. What is the difference between the highest and the second highest Value added (% of GDP) of Industry?
Keep it short and to the point. 0.57. What is the difference between the highest and the second highest Value added (% of GDP) in Manufacturing?
Give a very brief answer. 0.19. What is the difference between the highest and the second highest Value added (% of GDP) in Services?
Provide a short and direct response. 0.66. What is the difference between the highest and the second highest Value added (% of GDP) in Agriculture?
Provide a short and direct response. 0.93. What is the difference between the highest and the lowest Value added (% of GDP) of Industry?
Provide a succinct answer. 1.29. What is the difference between the highest and the lowest Value added (% of GDP) of Manufacturing?
Make the answer very short. 1.37. What is the difference between the highest and the lowest Value added (% of GDP) in Services?
Your response must be concise. 4.89. What is the difference between the highest and the lowest Value added (% of GDP) in Agriculture?
Your answer should be compact. 2.51. 